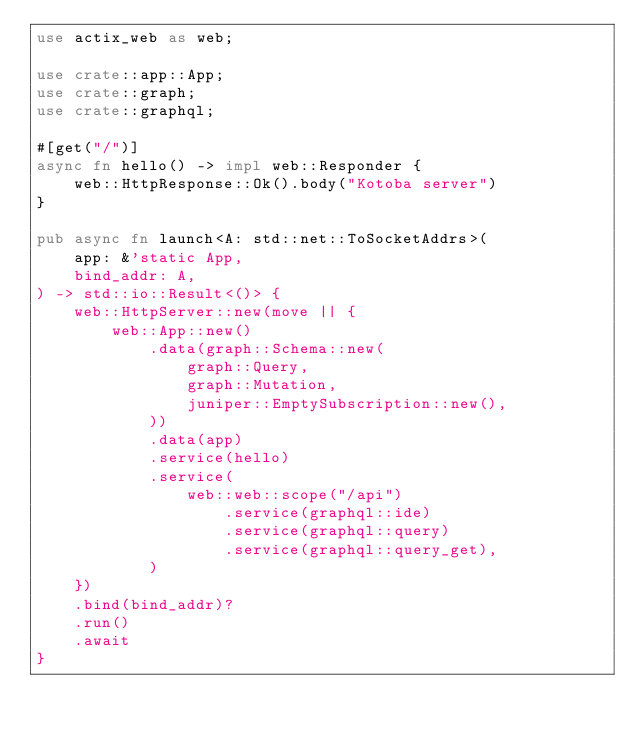<code> <loc_0><loc_0><loc_500><loc_500><_Rust_>use actix_web as web;

use crate::app::App;
use crate::graph;
use crate::graphql;

#[get("/")]
async fn hello() -> impl web::Responder {
	web::HttpResponse::Ok().body("Kotoba server")
}

pub async fn launch<A: std::net::ToSocketAddrs>(
	app: &'static App,
	bind_addr: A,
) -> std::io::Result<()> {
	web::HttpServer::new(move || {
		web::App::new()
			.data(graph::Schema::new(
				graph::Query,
				graph::Mutation,
				juniper::EmptySubscription::new(),
			))
			.data(app)
			.service(hello)
			.service(
				web::web::scope("/api")
					.service(graphql::ide)
					.service(graphql::query)
					.service(graphql::query_get),
			)
	})
	.bind(bind_addr)?
	.run()
	.await
}
</code> 